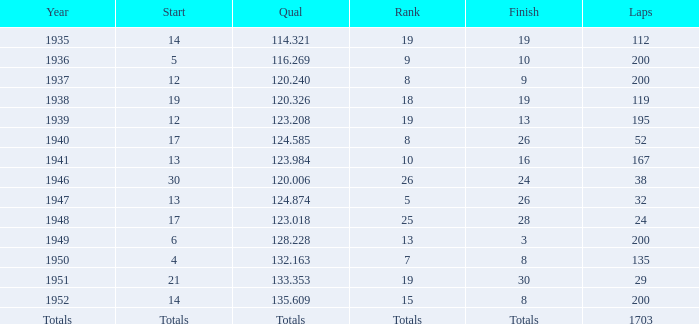In 1937, what was the finish? 9.0. 